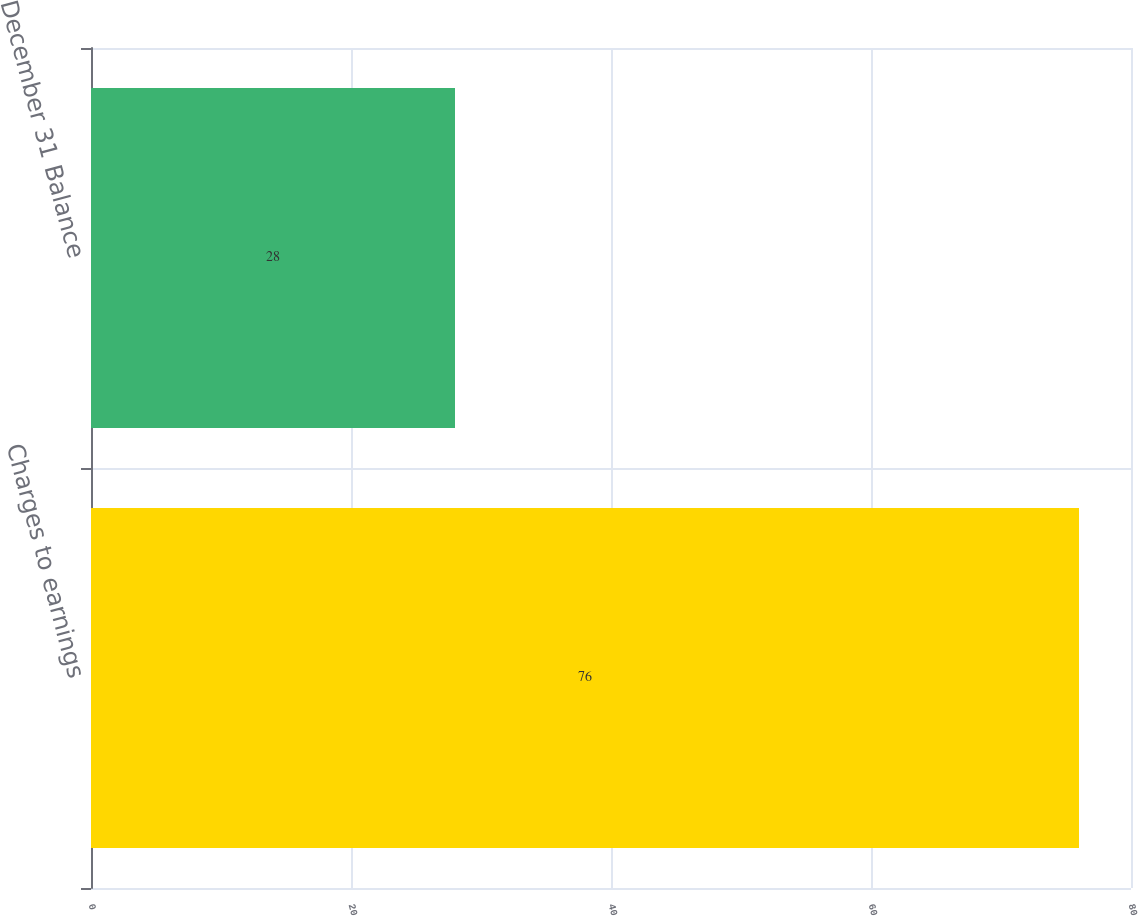Convert chart to OTSL. <chart><loc_0><loc_0><loc_500><loc_500><bar_chart><fcel>Charges to earnings<fcel>December 31 Balance<nl><fcel>76<fcel>28<nl></chart> 